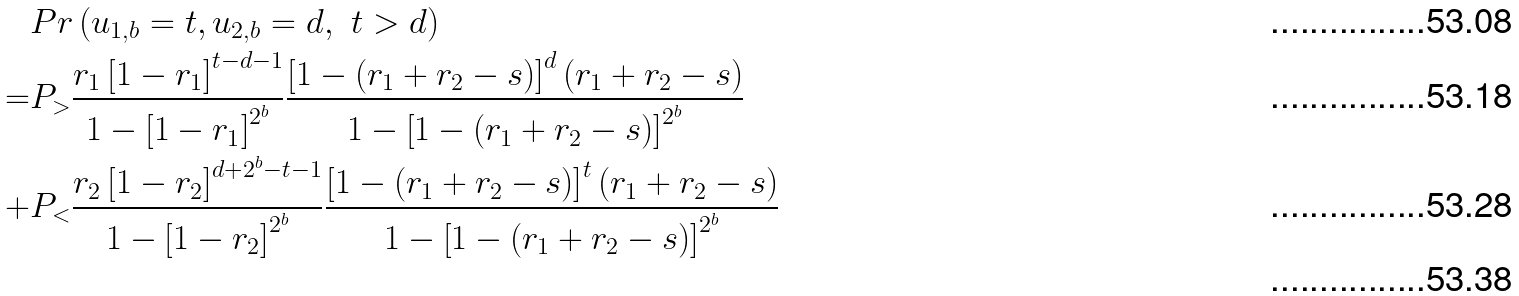Convert formula to latex. <formula><loc_0><loc_0><loc_500><loc_500>& P r \left ( u _ { 1 , b } = t , u _ { 2 , b } = d , \ t > d \right ) \\ = & P _ { > } \frac { r _ { 1 } \left [ 1 - r _ { 1 } \right ] ^ { t - d - 1 } } { 1 - \left [ 1 - r _ { 1 } \right ] ^ { 2 ^ { b } } } \frac { \left [ 1 - ( r _ { 1 } + r _ { 2 } - s ) \right ] ^ { d } ( r _ { 1 } + r _ { 2 } - s ) } { 1 - \left [ 1 - ( r _ { 1 } + r _ { 2 } - s ) \right ] ^ { 2 ^ { b } } } \\ + & P _ { < } \frac { r _ { 2 } \left [ 1 - r _ { 2 } \right ] ^ { d + 2 ^ { b } - t - 1 } } { 1 - \left [ 1 - r _ { 2 } \right ] ^ { 2 ^ { b } } } \frac { \left [ 1 - ( r _ { 1 } + r _ { 2 } - s ) \right ] ^ { t } ( r _ { 1 } + r _ { 2 } - s ) } { 1 - \left [ 1 - ( r _ { 1 } + r _ { 2 } - s ) \right ] ^ { 2 ^ { b } } } \\</formula> 